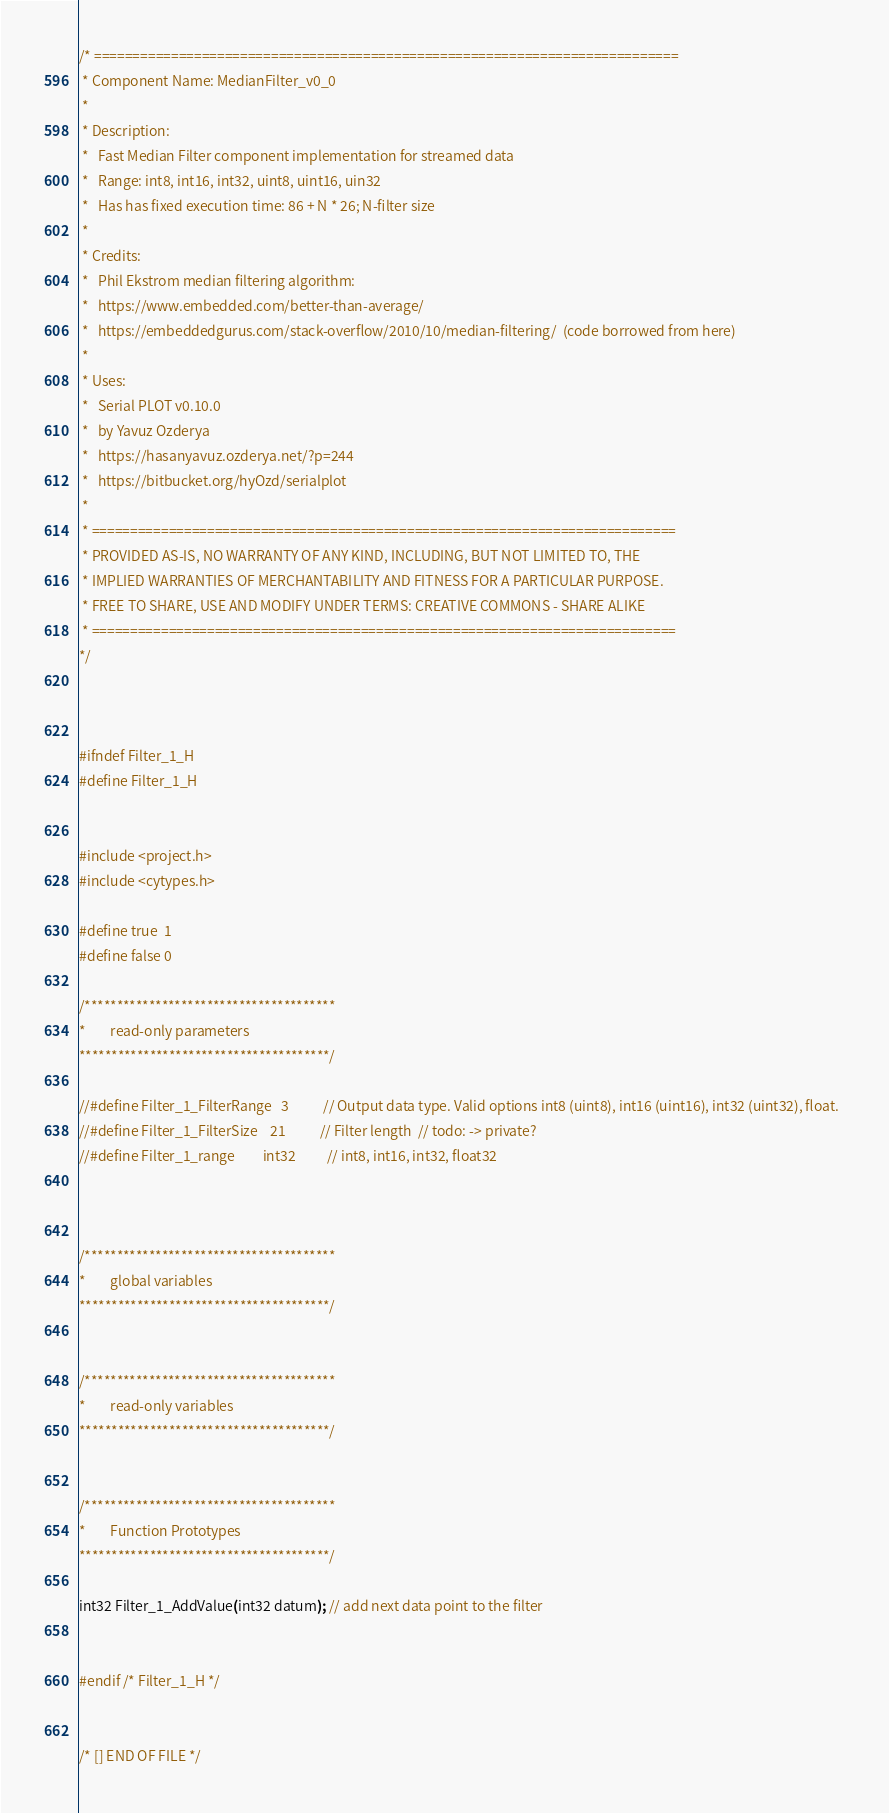<code> <loc_0><loc_0><loc_500><loc_500><_C_>/* ============================================================================
 * Component Name: MedianFilter_v0_0
 *
 * Description:
 *   Fast Median Filter component implementation for streamed data
 *   Range: int8, int16, int32, uint8, uint16, uin32
 *   Has has fixed execution time: 86 + N * 26; N-filter size
 *
 * Credits:
 *   Phil Ekstrom median filtering algorithm:
 *   https://www.embedded.com/better-than-average/
 *   https://embeddedgurus.com/stack-overflow/2010/10/median-filtering/  (code borrowed from here)
 *
 * Uses:
 *   Serial PLOT v0.10.0
 *   by Yavuz Ozderya
 *   https://hasanyavuz.ozderya.net/?p=244
 *   https://bitbucket.org/hyOzd/serialplot   
 *
 * ============================================================================
 * PROVIDED AS-IS, NO WARRANTY OF ANY KIND, INCLUDING, BUT NOT LIMITED TO, THE
 * IMPLIED WARRANTIES OF MERCHANTABILITY AND FITNESS FOR A PARTICULAR PURPOSE.
 * FREE TO SHARE, USE AND MODIFY UNDER TERMS: CREATIVE COMMONS - SHARE ALIKE
 * ============================================================================
*/



#ifndef Filter_1_H
#define Filter_1_H
 
    
#include <project.h>
#include <cytypes.h>
           
#define true  1
#define false 0

/***************************************
*        read-only parameters
***************************************/  

//#define Filter_1_FilterRange   3           // Output data type. Valid options int8 (uint8), int16 (uint16), int32 (uint32), float.  
//#define Filter_1_FilterSize    21           // Filter length  // todo: -> private?
//#define Filter_1_range         int32          // int8, int16, int32, float32   


    
/***************************************
*        global variables
***************************************/  
    

/***************************************
*        read-only variables
***************************************/    
 
    
/***************************************
*        Function Prototypes
***************************************/

int32 Filter_1_AddValue(int32 datum); // add next data point to the filter     

    
#endif /* Filter_1_H */


/* [] END OF FILE */
</code> 